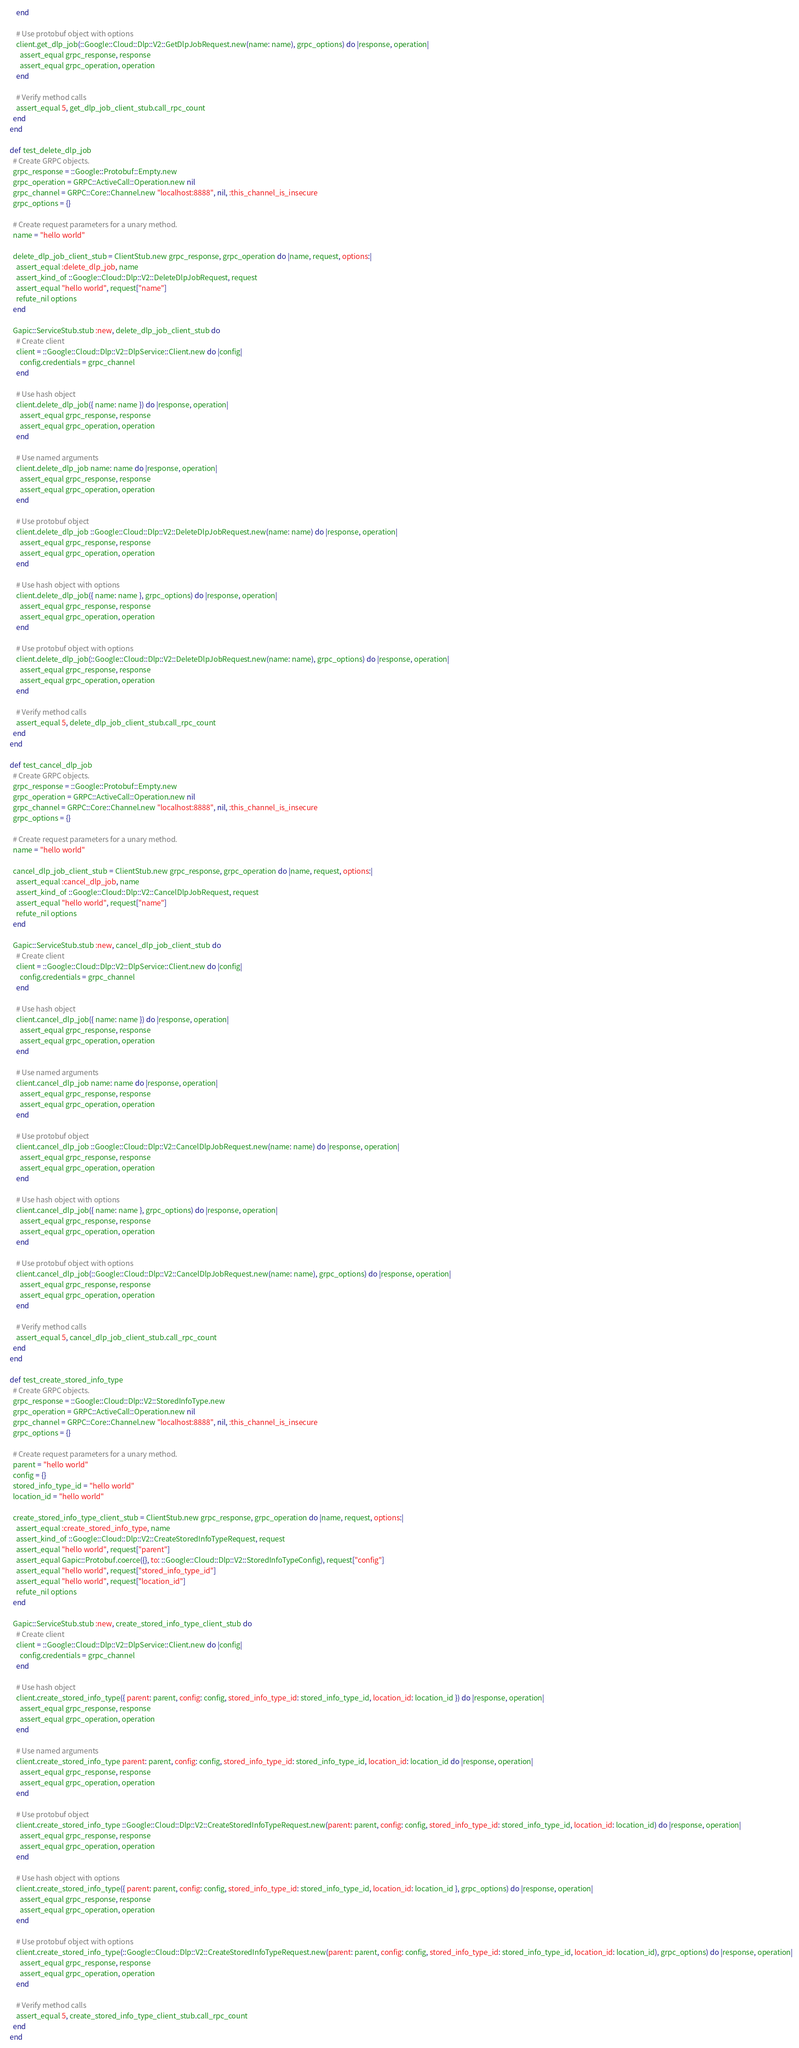Convert code to text. <code><loc_0><loc_0><loc_500><loc_500><_Ruby_>      end

      # Use protobuf object with options
      client.get_dlp_job(::Google::Cloud::Dlp::V2::GetDlpJobRequest.new(name: name), grpc_options) do |response, operation|
        assert_equal grpc_response, response
        assert_equal grpc_operation, operation
      end

      # Verify method calls
      assert_equal 5, get_dlp_job_client_stub.call_rpc_count
    end
  end

  def test_delete_dlp_job
    # Create GRPC objects.
    grpc_response = ::Google::Protobuf::Empty.new
    grpc_operation = GRPC::ActiveCall::Operation.new nil
    grpc_channel = GRPC::Core::Channel.new "localhost:8888", nil, :this_channel_is_insecure
    grpc_options = {}

    # Create request parameters for a unary method.
    name = "hello world"

    delete_dlp_job_client_stub = ClientStub.new grpc_response, grpc_operation do |name, request, options:|
      assert_equal :delete_dlp_job, name
      assert_kind_of ::Google::Cloud::Dlp::V2::DeleteDlpJobRequest, request
      assert_equal "hello world", request["name"]
      refute_nil options
    end

    Gapic::ServiceStub.stub :new, delete_dlp_job_client_stub do
      # Create client
      client = ::Google::Cloud::Dlp::V2::DlpService::Client.new do |config|
        config.credentials = grpc_channel
      end

      # Use hash object
      client.delete_dlp_job({ name: name }) do |response, operation|
        assert_equal grpc_response, response
        assert_equal grpc_operation, operation
      end

      # Use named arguments
      client.delete_dlp_job name: name do |response, operation|
        assert_equal grpc_response, response
        assert_equal grpc_operation, operation
      end

      # Use protobuf object
      client.delete_dlp_job ::Google::Cloud::Dlp::V2::DeleteDlpJobRequest.new(name: name) do |response, operation|
        assert_equal grpc_response, response
        assert_equal grpc_operation, operation
      end

      # Use hash object with options
      client.delete_dlp_job({ name: name }, grpc_options) do |response, operation|
        assert_equal grpc_response, response
        assert_equal grpc_operation, operation
      end

      # Use protobuf object with options
      client.delete_dlp_job(::Google::Cloud::Dlp::V2::DeleteDlpJobRequest.new(name: name), grpc_options) do |response, operation|
        assert_equal grpc_response, response
        assert_equal grpc_operation, operation
      end

      # Verify method calls
      assert_equal 5, delete_dlp_job_client_stub.call_rpc_count
    end
  end

  def test_cancel_dlp_job
    # Create GRPC objects.
    grpc_response = ::Google::Protobuf::Empty.new
    grpc_operation = GRPC::ActiveCall::Operation.new nil
    grpc_channel = GRPC::Core::Channel.new "localhost:8888", nil, :this_channel_is_insecure
    grpc_options = {}

    # Create request parameters for a unary method.
    name = "hello world"

    cancel_dlp_job_client_stub = ClientStub.new grpc_response, grpc_operation do |name, request, options:|
      assert_equal :cancel_dlp_job, name
      assert_kind_of ::Google::Cloud::Dlp::V2::CancelDlpJobRequest, request
      assert_equal "hello world", request["name"]
      refute_nil options
    end

    Gapic::ServiceStub.stub :new, cancel_dlp_job_client_stub do
      # Create client
      client = ::Google::Cloud::Dlp::V2::DlpService::Client.new do |config|
        config.credentials = grpc_channel
      end

      # Use hash object
      client.cancel_dlp_job({ name: name }) do |response, operation|
        assert_equal grpc_response, response
        assert_equal grpc_operation, operation
      end

      # Use named arguments
      client.cancel_dlp_job name: name do |response, operation|
        assert_equal grpc_response, response
        assert_equal grpc_operation, operation
      end

      # Use protobuf object
      client.cancel_dlp_job ::Google::Cloud::Dlp::V2::CancelDlpJobRequest.new(name: name) do |response, operation|
        assert_equal grpc_response, response
        assert_equal grpc_operation, operation
      end

      # Use hash object with options
      client.cancel_dlp_job({ name: name }, grpc_options) do |response, operation|
        assert_equal grpc_response, response
        assert_equal grpc_operation, operation
      end

      # Use protobuf object with options
      client.cancel_dlp_job(::Google::Cloud::Dlp::V2::CancelDlpJobRequest.new(name: name), grpc_options) do |response, operation|
        assert_equal grpc_response, response
        assert_equal grpc_operation, operation
      end

      # Verify method calls
      assert_equal 5, cancel_dlp_job_client_stub.call_rpc_count
    end
  end

  def test_create_stored_info_type
    # Create GRPC objects.
    grpc_response = ::Google::Cloud::Dlp::V2::StoredInfoType.new
    grpc_operation = GRPC::ActiveCall::Operation.new nil
    grpc_channel = GRPC::Core::Channel.new "localhost:8888", nil, :this_channel_is_insecure
    grpc_options = {}

    # Create request parameters for a unary method.
    parent = "hello world"
    config = {}
    stored_info_type_id = "hello world"
    location_id = "hello world"

    create_stored_info_type_client_stub = ClientStub.new grpc_response, grpc_operation do |name, request, options:|
      assert_equal :create_stored_info_type, name
      assert_kind_of ::Google::Cloud::Dlp::V2::CreateStoredInfoTypeRequest, request
      assert_equal "hello world", request["parent"]
      assert_equal Gapic::Protobuf.coerce({}, to: ::Google::Cloud::Dlp::V2::StoredInfoTypeConfig), request["config"]
      assert_equal "hello world", request["stored_info_type_id"]
      assert_equal "hello world", request["location_id"]
      refute_nil options
    end

    Gapic::ServiceStub.stub :new, create_stored_info_type_client_stub do
      # Create client
      client = ::Google::Cloud::Dlp::V2::DlpService::Client.new do |config|
        config.credentials = grpc_channel
      end

      # Use hash object
      client.create_stored_info_type({ parent: parent, config: config, stored_info_type_id: stored_info_type_id, location_id: location_id }) do |response, operation|
        assert_equal grpc_response, response
        assert_equal grpc_operation, operation
      end

      # Use named arguments
      client.create_stored_info_type parent: parent, config: config, stored_info_type_id: stored_info_type_id, location_id: location_id do |response, operation|
        assert_equal grpc_response, response
        assert_equal grpc_operation, operation
      end

      # Use protobuf object
      client.create_stored_info_type ::Google::Cloud::Dlp::V2::CreateStoredInfoTypeRequest.new(parent: parent, config: config, stored_info_type_id: stored_info_type_id, location_id: location_id) do |response, operation|
        assert_equal grpc_response, response
        assert_equal grpc_operation, operation
      end

      # Use hash object with options
      client.create_stored_info_type({ parent: parent, config: config, stored_info_type_id: stored_info_type_id, location_id: location_id }, grpc_options) do |response, operation|
        assert_equal grpc_response, response
        assert_equal grpc_operation, operation
      end

      # Use protobuf object with options
      client.create_stored_info_type(::Google::Cloud::Dlp::V2::CreateStoredInfoTypeRequest.new(parent: parent, config: config, stored_info_type_id: stored_info_type_id, location_id: location_id), grpc_options) do |response, operation|
        assert_equal grpc_response, response
        assert_equal grpc_operation, operation
      end

      # Verify method calls
      assert_equal 5, create_stored_info_type_client_stub.call_rpc_count
    end
  end
</code> 